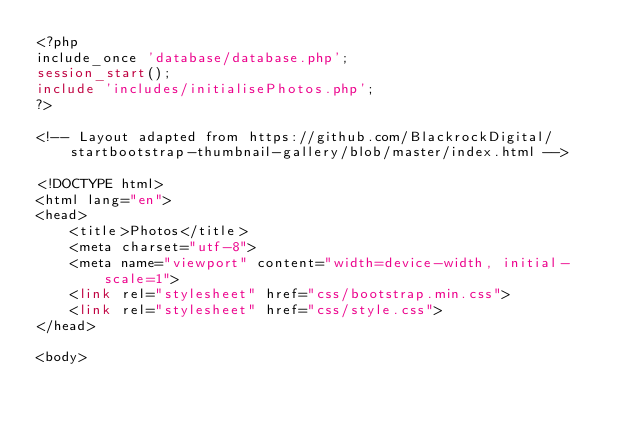Convert code to text. <code><loc_0><loc_0><loc_500><loc_500><_PHP_><?php
include_once 'database/database.php';
session_start();
include 'includes/initialisePhotos.php';
?>

<!-- Layout adapted from https://github.com/BlackrockDigital/startbootstrap-thumbnail-gallery/blob/master/index.html -->

<!DOCTYPE html>
<html lang="en">
<head>
    <title>Photos</title>
    <meta charset="utf-8">
    <meta name="viewport" content="width=device-width, initial-scale=1">
    <link rel="stylesheet" href="css/bootstrap.min.css">
    <link rel="stylesheet" href="css/style.css">
</head>

<body></code> 